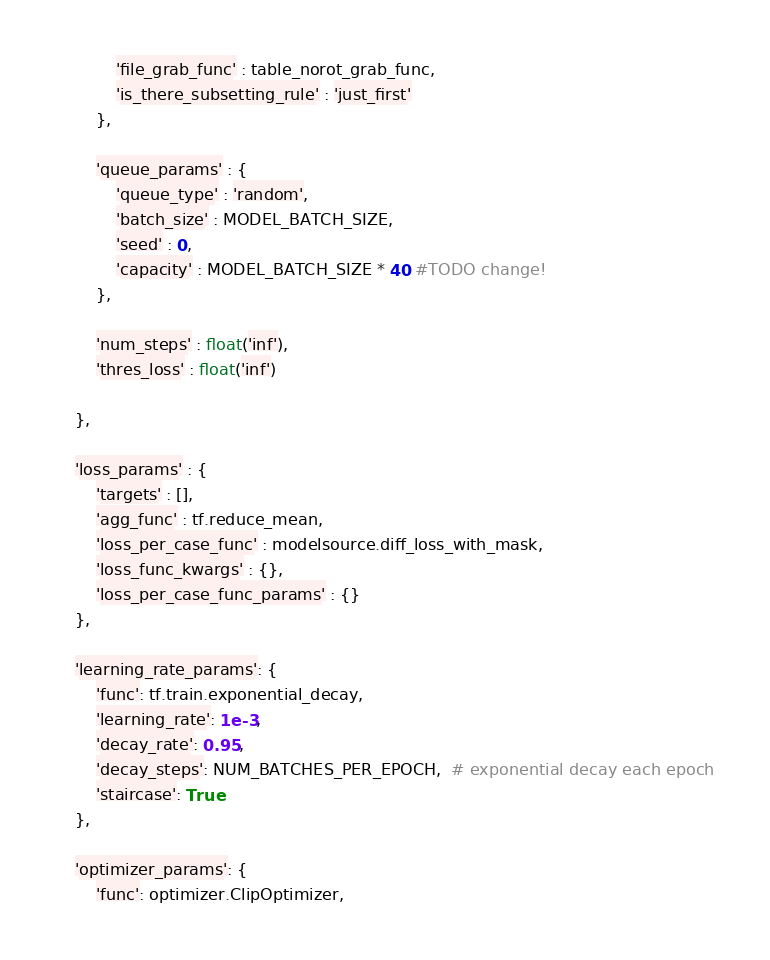<code> <loc_0><loc_0><loc_500><loc_500><_Python_>			'file_grab_func' : table_norot_grab_func,
			'is_there_subsetting_rule' : 'just_first'
		},

		'queue_params' : {
			'queue_type' : 'random',
			'batch_size' : MODEL_BATCH_SIZE,
			'seed' : 0,
			'capacity' : MODEL_BATCH_SIZE * 40 #TODO change!
		},

		'num_steps' : float('inf'),
		'thres_loss' : float('inf')

	},

	'loss_params' : {
		'targets' : [],
		'agg_func' : tf.reduce_mean,
		'loss_per_case_func' : modelsource.diff_loss_with_mask,
		'loss_func_kwargs' : {},
		'loss_per_case_func_params' : {}
	},

	'learning_rate_params': {
		'func': tf.train.exponential_decay,
		'learning_rate': 1e-3,
		'decay_rate': 0.95,
		'decay_steps': NUM_BATCHES_PER_EPOCH,  # exponential decay each epoch
		'staircase': True
	},

	'optimizer_params': {
		'func': optimizer.ClipOptimizer,</code> 